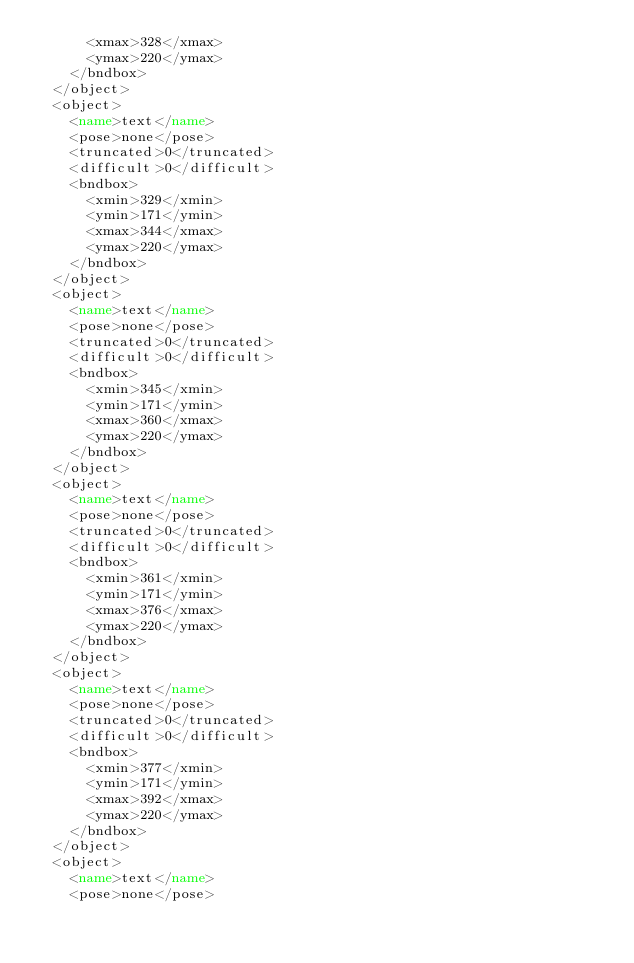<code> <loc_0><loc_0><loc_500><loc_500><_XML_>			<xmax>328</xmax>
			<ymax>220</ymax>
		</bndbox>
	</object>
	<object>
		<name>text</name>
		<pose>none</pose>
		<truncated>0</truncated>
		<difficult>0</difficult>
		<bndbox>
			<xmin>329</xmin>
			<ymin>171</ymin>
			<xmax>344</xmax>
			<ymax>220</ymax>
		</bndbox>
	</object>
	<object>
		<name>text</name>
		<pose>none</pose>
		<truncated>0</truncated>
		<difficult>0</difficult>
		<bndbox>
			<xmin>345</xmin>
			<ymin>171</ymin>
			<xmax>360</xmax>
			<ymax>220</ymax>
		</bndbox>
	</object>
	<object>
		<name>text</name>
		<pose>none</pose>
		<truncated>0</truncated>
		<difficult>0</difficult>
		<bndbox>
			<xmin>361</xmin>
			<ymin>171</ymin>
			<xmax>376</xmax>
			<ymax>220</ymax>
		</bndbox>
	</object>
	<object>
		<name>text</name>
		<pose>none</pose>
		<truncated>0</truncated>
		<difficult>0</difficult>
		<bndbox>
			<xmin>377</xmin>
			<ymin>171</ymin>
			<xmax>392</xmax>
			<ymax>220</ymax>
		</bndbox>
	</object>
	<object>
		<name>text</name>
		<pose>none</pose></code> 